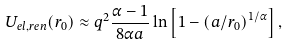<formula> <loc_0><loc_0><loc_500><loc_500>U _ { e l , r e n } ( r _ { 0 } ) \approx q ^ { 2 } \frac { \alpha - 1 } { 8 \alpha a } \ln \left [ 1 - \left ( a / r _ { 0 } \right ) ^ { 1 / \alpha } \right ] , \,</formula> 